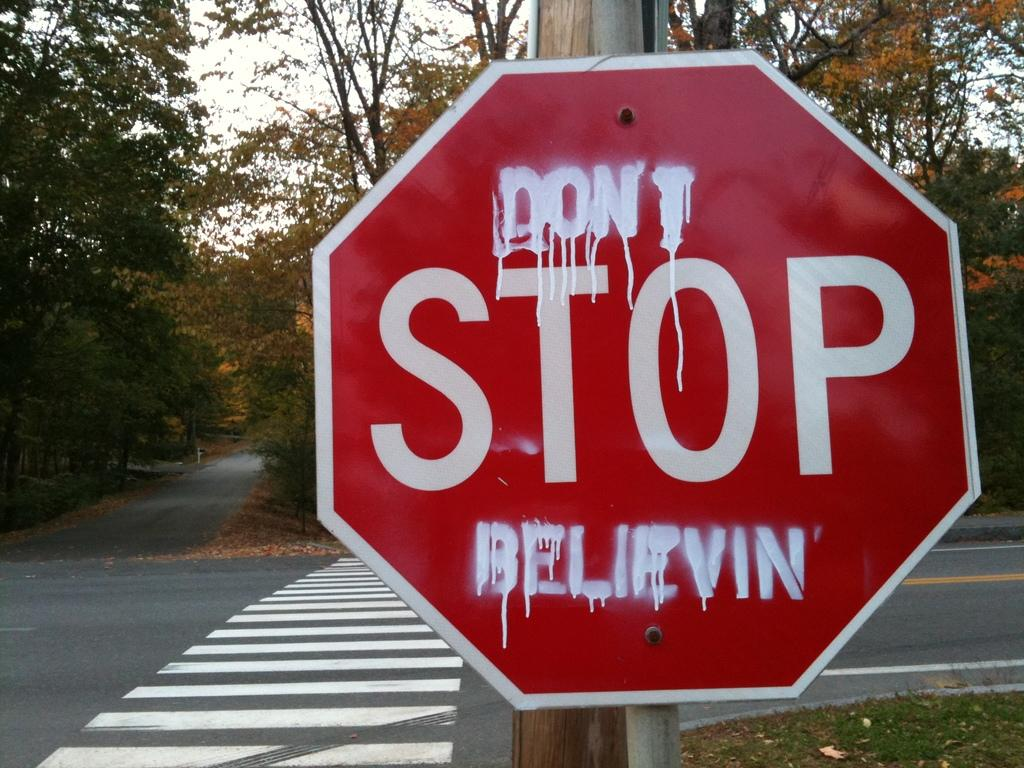What is the main object in the image? There is a stop board in the image. What can be seen on the road in the image? There is a zebra crossing on the road in the image. What type of vegetation is visible in the background of the image? There are trees in the background of the image. What is visible at the top of the image? The sky is visible at the top of the image. What type of feast is being prepared in the image? There is no feast or any indication of food preparation in the image. What time of day might the image represent, considering the presence of the zebra crossing and stop board? The image does not provide enough information to determine the time of day. 